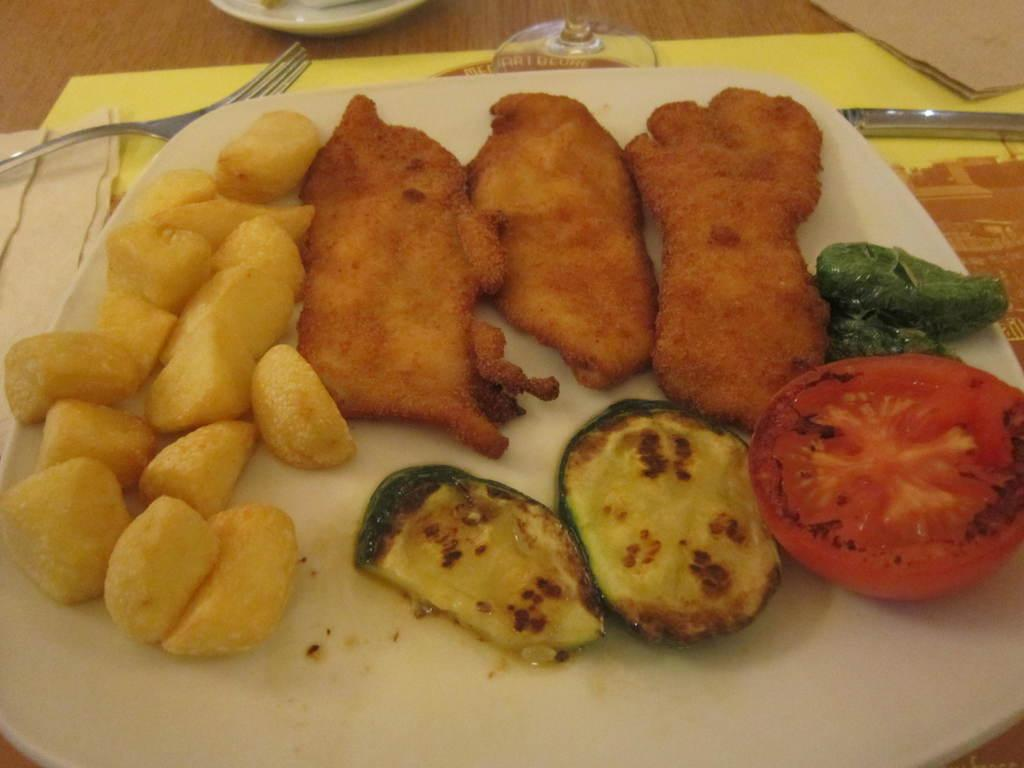What is on the plate that is visible in the image? There is a plate with food in the image. What color is the plate? The plate is white. What utensils are visible in the image? There is a fork and a knife in the image. What else can be seen on the table in the image? There are other items on the table. What type of wax is being used in the image? There is no wax present in the image. 